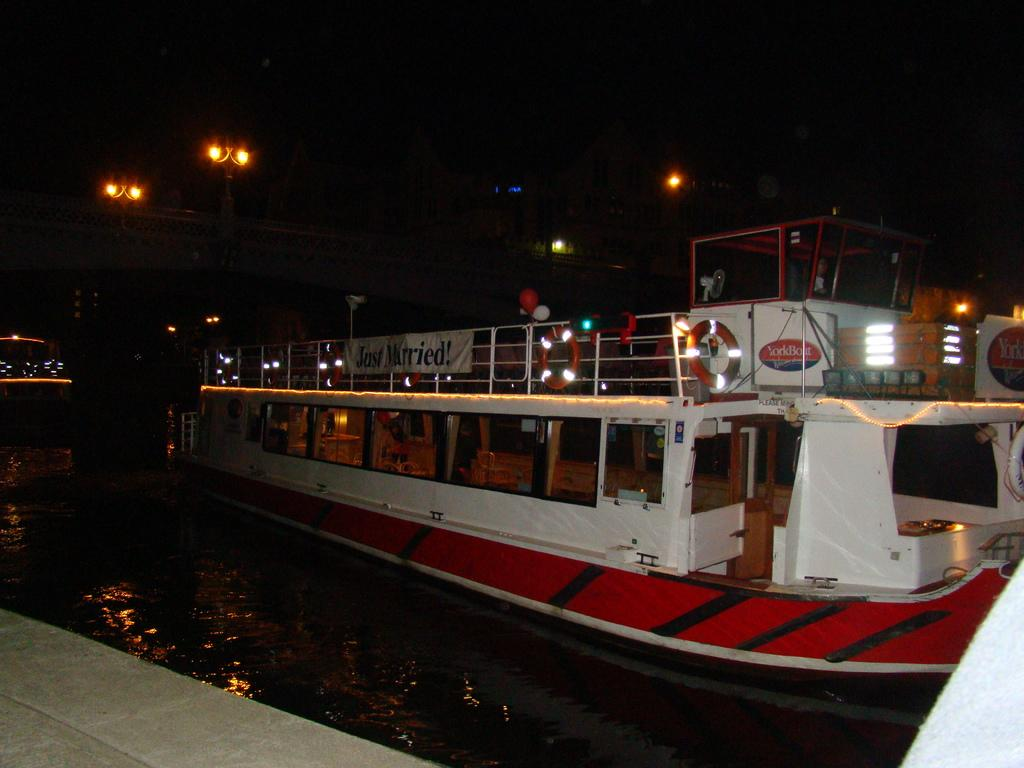What structure can be seen crossing over the water in the image? There is a bridge in the image. What type of vehicles can be seen in the water? There are boats in the water. What type of lighting is present near the bridge? Pole lights are visible in the image. What type of lighting is present on the boats? Lights on the boat are present in the image. Can you tell me how many snails are crawling on the bridge in the image? There are no snails present on the bridge in the image. What color are the eyes of the person operating the boat in the image? There are no people or eyes visible in the image; it only shows a bridge, boats, pole lights, and lights on the boats. 